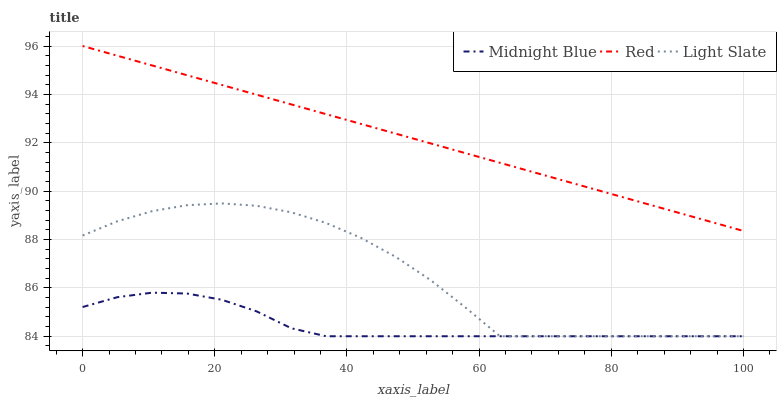Does Midnight Blue have the minimum area under the curve?
Answer yes or no. Yes. Does Red have the maximum area under the curve?
Answer yes or no. Yes. Does Red have the minimum area under the curve?
Answer yes or no. No. Does Midnight Blue have the maximum area under the curve?
Answer yes or no. No. Is Red the smoothest?
Answer yes or no. Yes. Is Light Slate the roughest?
Answer yes or no. Yes. Is Midnight Blue the smoothest?
Answer yes or no. No. Is Midnight Blue the roughest?
Answer yes or no. No. Does Light Slate have the lowest value?
Answer yes or no. Yes. Does Red have the lowest value?
Answer yes or no. No. Does Red have the highest value?
Answer yes or no. Yes. Does Midnight Blue have the highest value?
Answer yes or no. No. Is Light Slate less than Red?
Answer yes or no. Yes. Is Red greater than Midnight Blue?
Answer yes or no. Yes. Does Light Slate intersect Midnight Blue?
Answer yes or no. Yes. Is Light Slate less than Midnight Blue?
Answer yes or no. No. Is Light Slate greater than Midnight Blue?
Answer yes or no. No. Does Light Slate intersect Red?
Answer yes or no. No. 